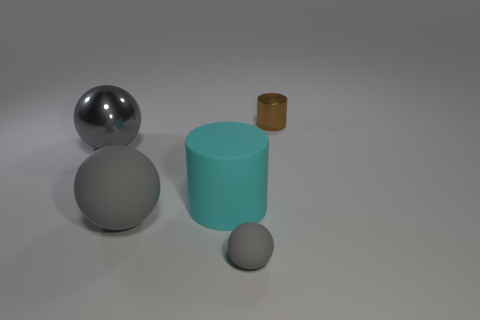Subtract all big spheres. How many spheres are left? 1 Subtract 1 balls. How many balls are left? 2 Add 5 small gray balls. How many objects exist? 10 Subtract all cyan balls. Subtract all green blocks. How many balls are left? 3 Subtract all cylinders. How many objects are left? 3 Add 5 brown metal things. How many brown metal things exist? 6 Subtract 0 blue cylinders. How many objects are left? 5 Subtract all gray rubber things. Subtract all tiny rubber balls. How many objects are left? 2 Add 3 tiny rubber spheres. How many tiny rubber spheres are left? 4 